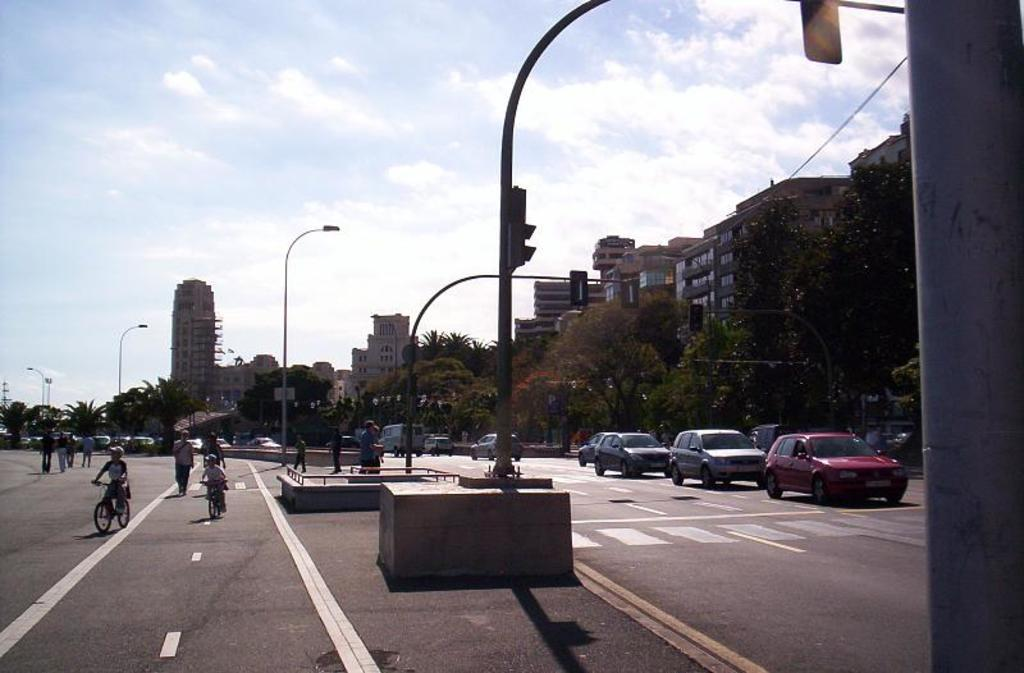What is happening on the road in the image? There are vehicles moving on the road in the image. What can be seen in the middle of the image? There are poles in the middle of the image. What is visible in the background of the image? There are trees, buildings, and clouds in the sky in the background of the image. What type of vegetable is being used as a line to separate the lanes on the road in the image? There is no vegetable being used as a line to separate the lanes on the road in the image. The lines are likely painted on the road, and vegetables are not involved in this context. 